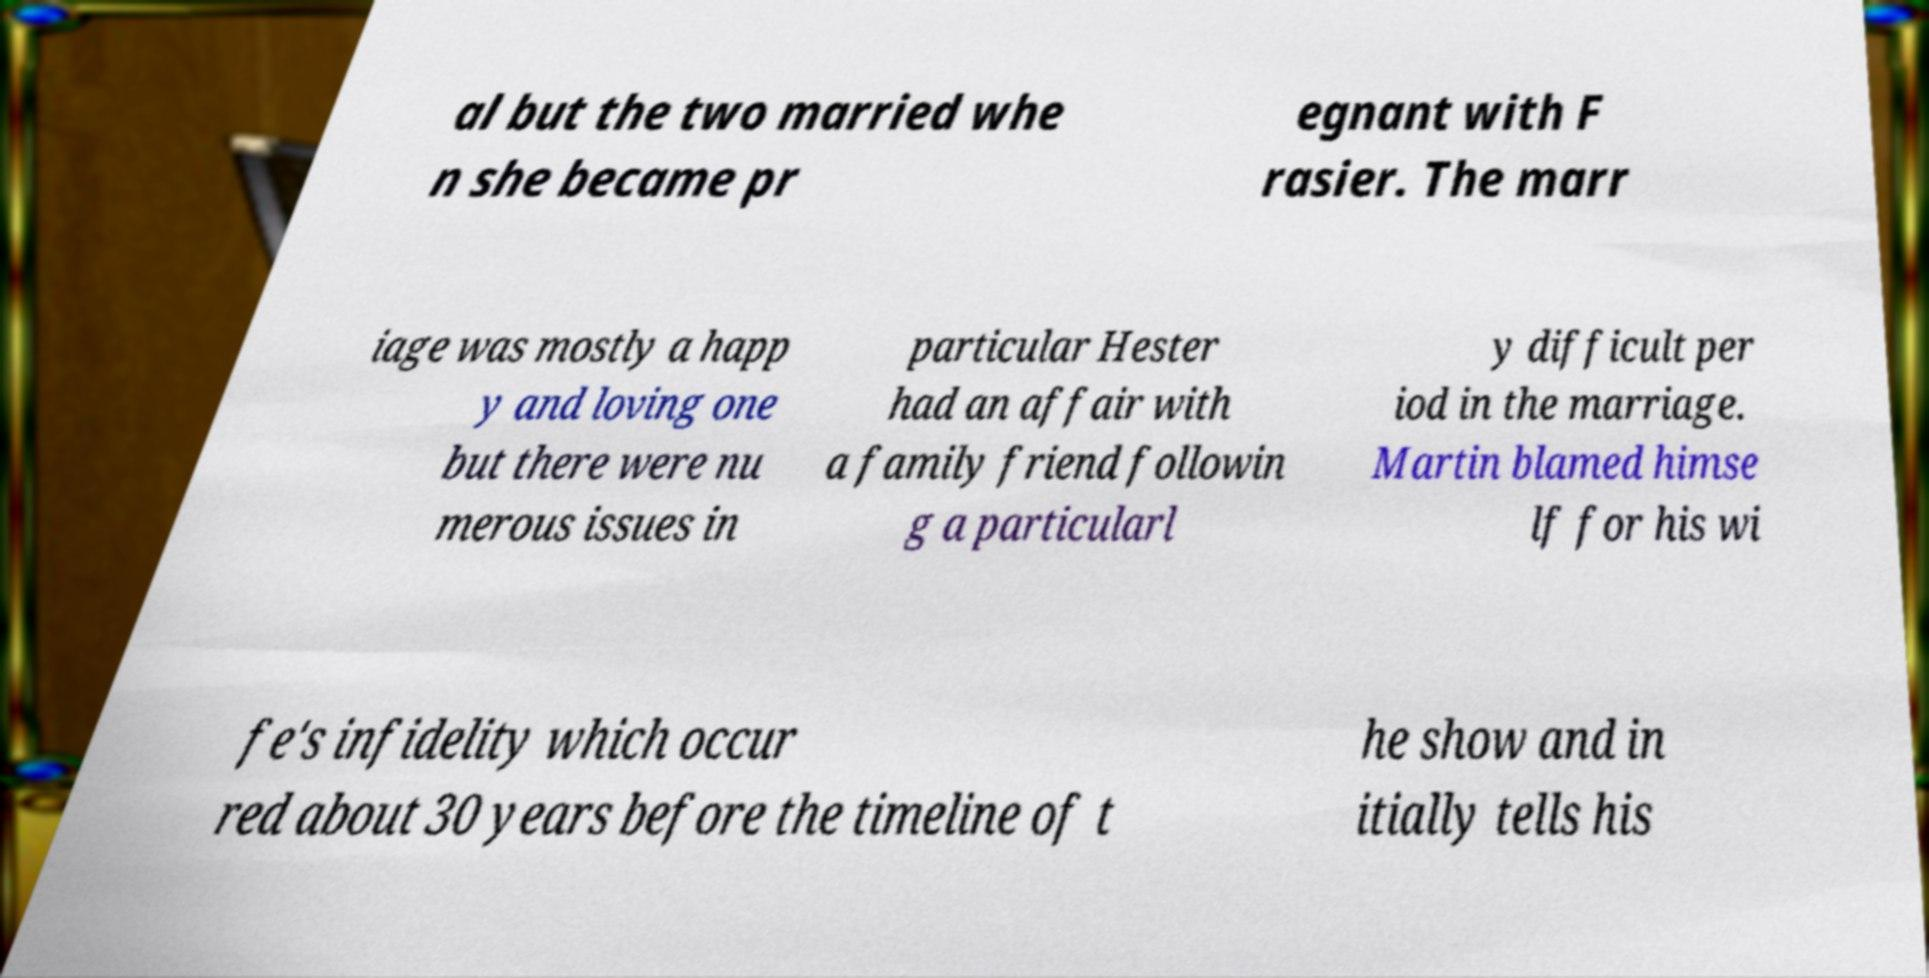What messages or text are displayed in this image? I need them in a readable, typed format. al but the two married whe n she became pr egnant with F rasier. The marr iage was mostly a happ y and loving one but there were nu merous issues in particular Hester had an affair with a family friend followin g a particularl y difficult per iod in the marriage. Martin blamed himse lf for his wi fe's infidelity which occur red about 30 years before the timeline of t he show and in itially tells his 